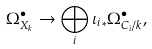Convert formula to latex. <formula><loc_0><loc_0><loc_500><loc_500>\Omega ^ { \bullet } _ { X _ { k } } \rightarrow \bigoplus _ { i } { \iota _ { i } } _ { * } \Omega ^ { \bullet } _ { C _ { i } / k } ,</formula> 